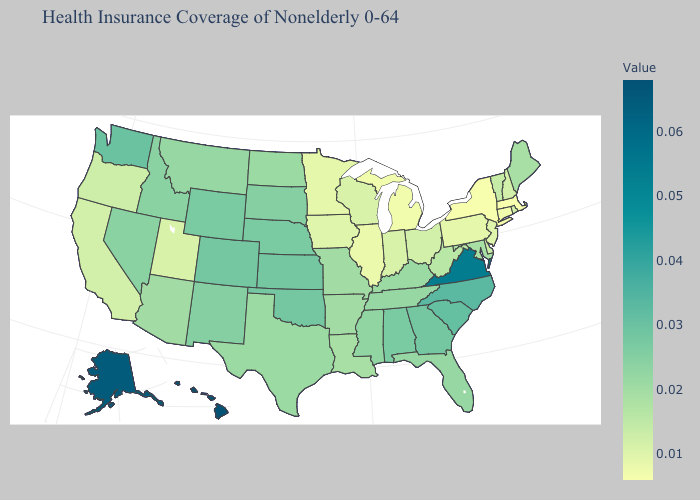Among the states that border Ohio , which have the lowest value?
Give a very brief answer. Michigan. Among the states that border Illinois , does Kentucky have the highest value?
Answer briefly. Yes. Does Minnesota have the highest value in the MidWest?
Keep it brief. No. Among the states that border Connecticut , does New York have the highest value?
Answer briefly. No. Among the states that border South Carolina , does Georgia have the highest value?
Quick response, please. No. 